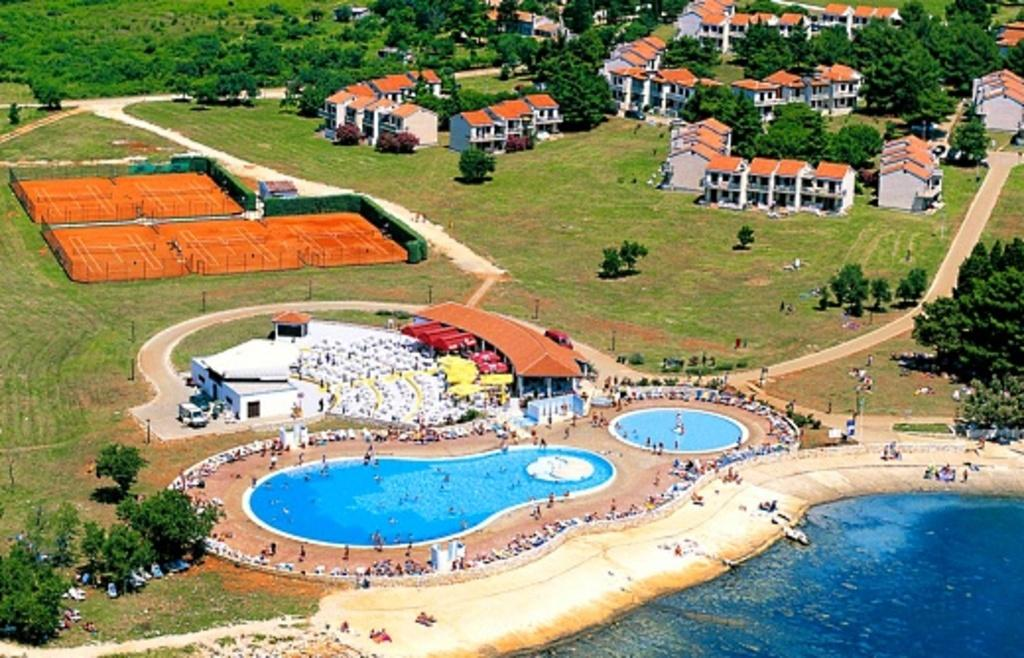What is the primary element in the image? There is water in the image. What type of recreational facility can be seen in the image? There are swimming pools in the image. Can you describe the people in the image? There are people in the image. What type of vegetation is present in the image? There is grass, plants, and trees in the image. What type of infrastructure is visible in the image? There are vehicles on the road and houses in the image. What type of leisure area is present in the image? There is a playground in the image. What type of pump is being used by the mother in the image? There is no mother or pump present in the image. 